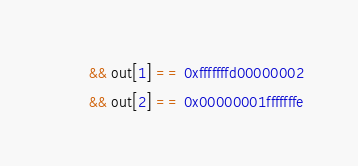Convert code to text. <code><loc_0><loc_0><loc_500><loc_500><_C_>        && out[1] == 0xfffffffd00000002
        && out[2] == 0x00000001fffffffe</code> 